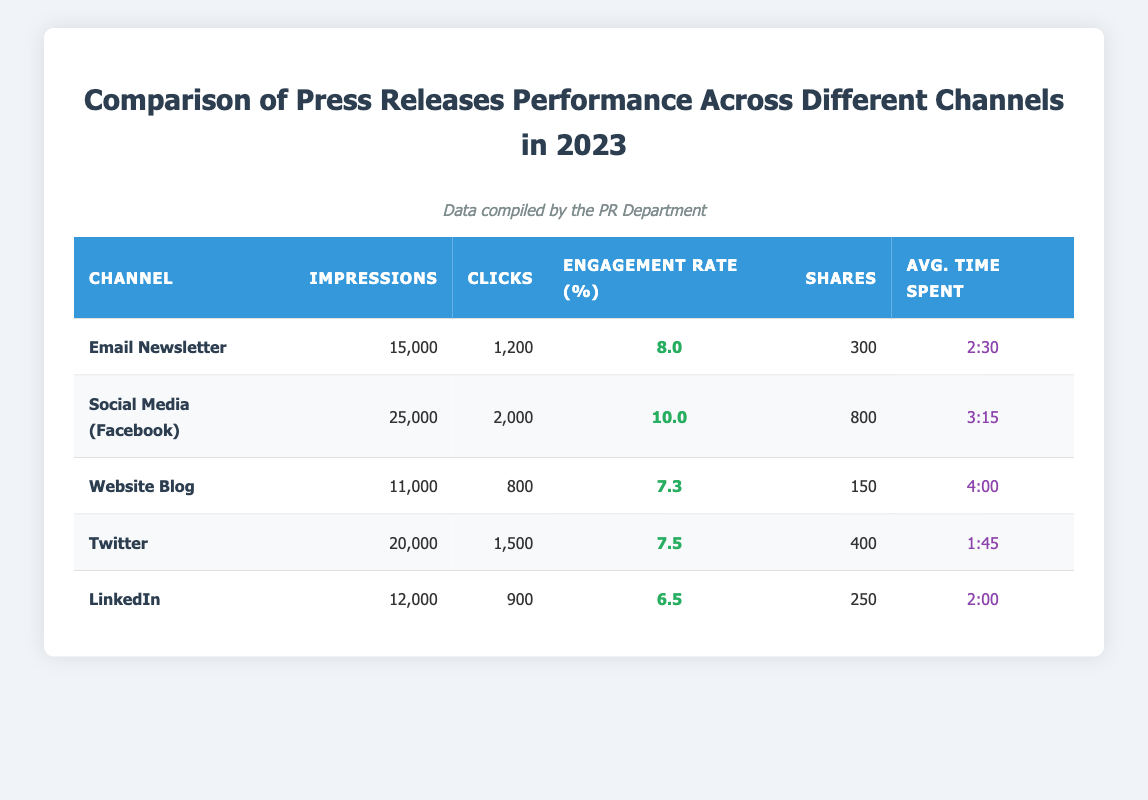What is the total number of impressions across all channels? To find the total number of impressions, sum the impressions for each channel: 15000 + 25000 + 11000 + 20000 + 12000 = 83000.
Answer: 83000 Which channel had the highest engagement rate? From the table, the engagement rates are as follows: Email Newsletter: 8.0, Social Media (Facebook): 10.0, Website Blog: 7.3, Twitter: 7.5, LinkedIn: 6.5. The highest is 10.0 for Social Media (Facebook).
Answer: Social Media (Facebook) Did the Website Blog have more clicks than LinkedIn? The clicks for the Website Blog are 800, and for LinkedIn, they are 900. Since 800 is less than 900, the Website Blog did not have more clicks than LinkedIn.
Answer: No What is the average time spent on the Email Newsletter and Social Media (Facebook) channels? The average time spent for the Email Newsletter is 2:30 (150 seconds) and for Social Media (Facebook) is 3:15 (195 seconds). The total time is 150 + 195 = 345 seconds. The average time is 345 / 2 = 172.5 seconds, which converts to 2:52.
Answer: 2:52 How many total shares were generated from all channels combined? The shares for each channel are: Email Newsletter: 300, Social Media (Facebook): 800, Website Blog: 150, Twitter: 400, LinkedIn: 250. Summing these gives 300 + 800 + 150 + 400 + 250 = 1900 total shares.
Answer: 1900 Is the average time spent on the Website Blog greater than that on Twitter? The average time spent on the Website Blog is 4:00 (240 seconds) and for Twitter it is 1:45 (105 seconds). Since 240 is greater than 105, the average time spent on the Website Blog is indeed greater than on Twitter.
Answer: Yes What is the difference in clicks between the Social Media (Facebook) channel and the Twitter channel? The clicks for Social Media (Facebook) are 2000, and for Twitter, they are 1500. The difference is 2000 - 1500 = 500.
Answer: 500 Which channel had the lowest number of impressions, and what was that number? The impressions for each channel are: Email Newsletter: 15000, Social Media (Facebook): 25000, Website Blog: 11000, Twitter: 20000, LinkedIn: 12000. The lowest number of impressions is 11000 for the Website Blog.
Answer: Website Blog, 11000 